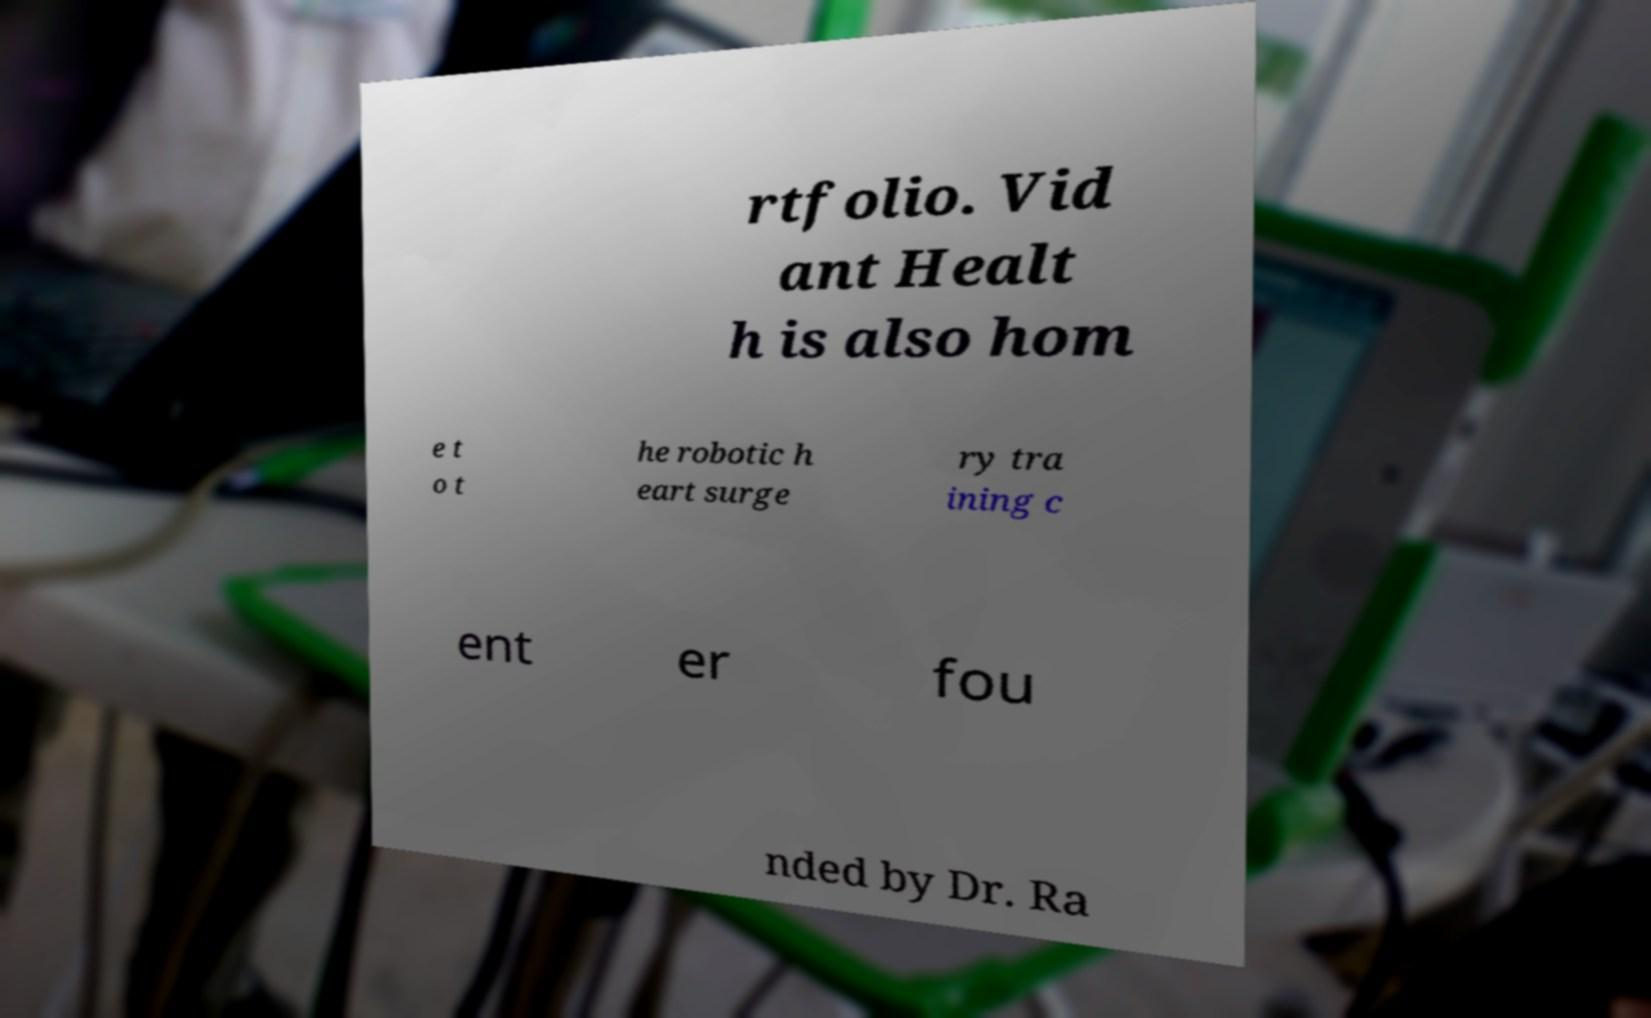Can you accurately transcribe the text from the provided image for me? rtfolio. Vid ant Healt h is also hom e t o t he robotic h eart surge ry tra ining c ent er fou nded by Dr. Ra 